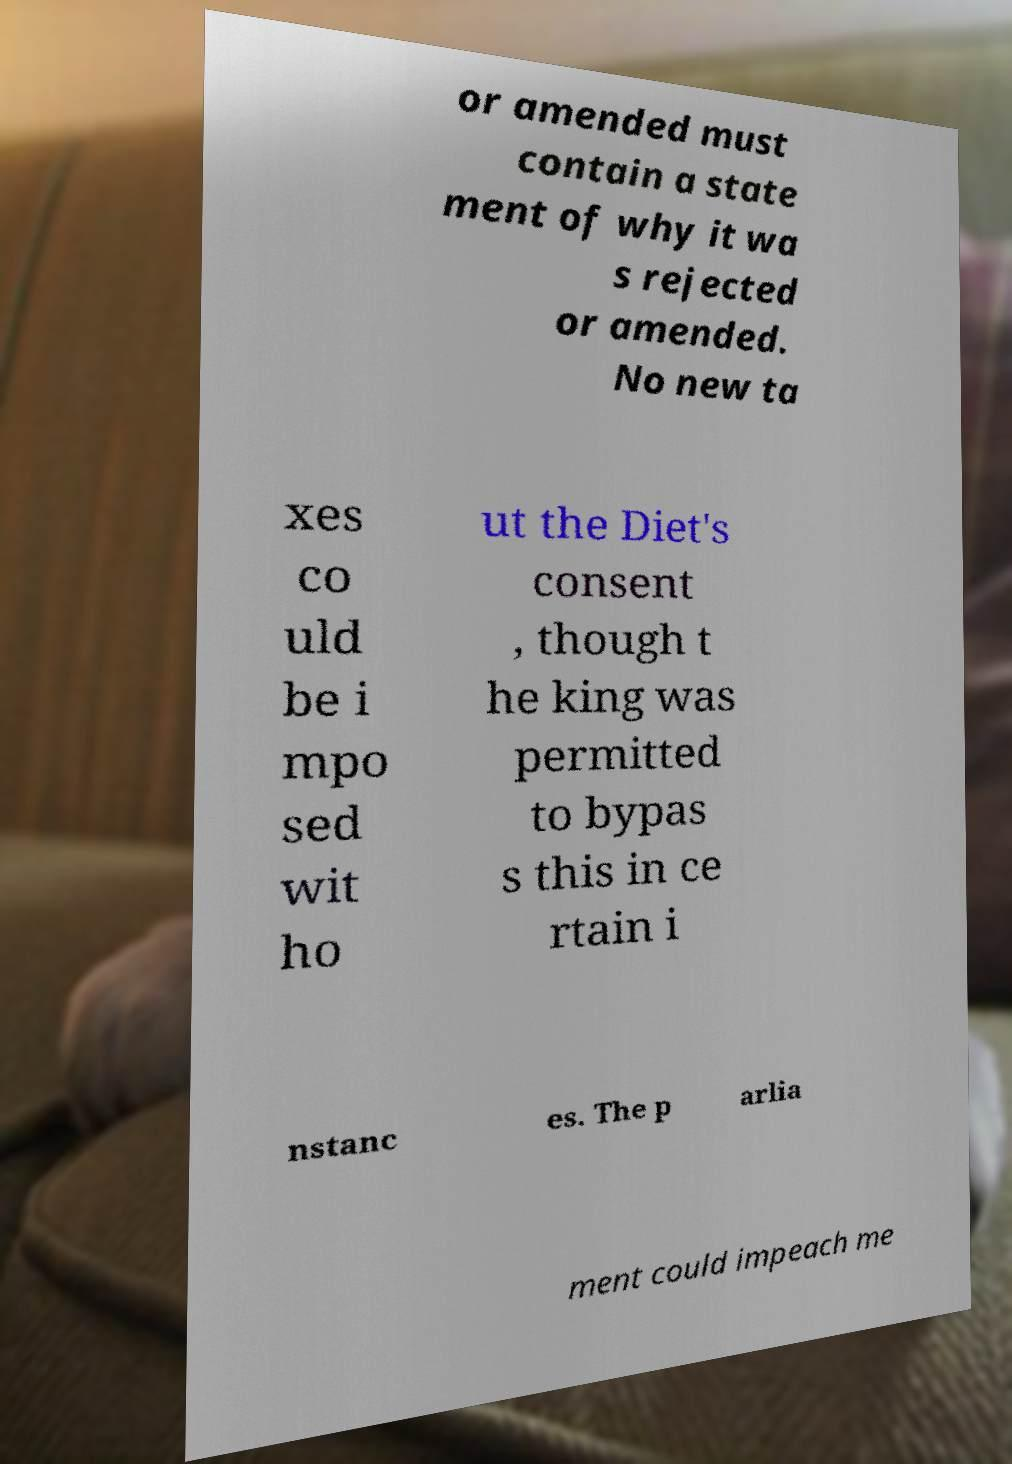I need the written content from this picture converted into text. Can you do that? or amended must contain a state ment of why it wa s rejected or amended. No new ta xes co uld be i mpo sed wit ho ut the Diet's consent , though t he king was permitted to bypas s this in ce rtain i nstanc es. The p arlia ment could impeach me 